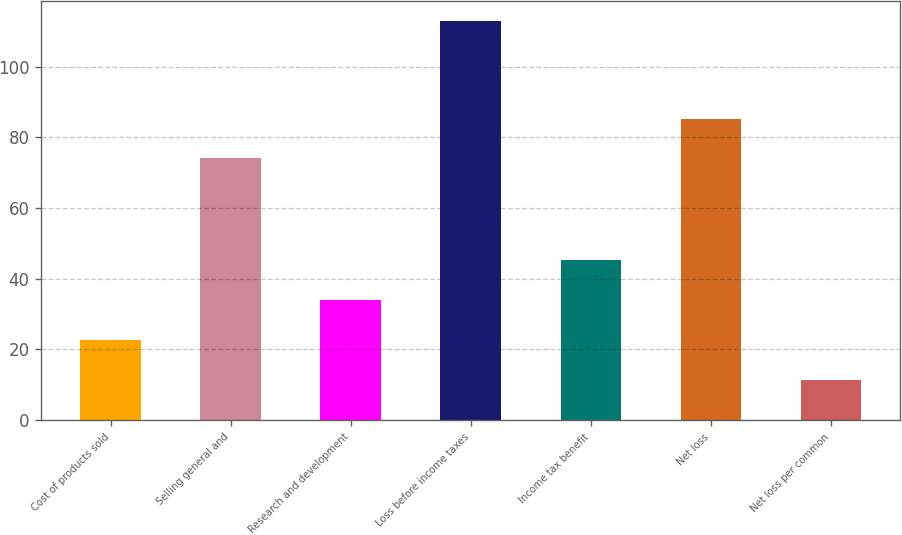Convert chart to OTSL. <chart><loc_0><loc_0><loc_500><loc_500><bar_chart><fcel>Cost of products sold<fcel>Selling general and<fcel>Research and development<fcel>Loss before income taxes<fcel>Income tax benefit<fcel>Net loss<fcel>Net loss per common<nl><fcel>22.64<fcel>74<fcel>33.93<fcel>113<fcel>45.22<fcel>85.29<fcel>11.35<nl></chart> 